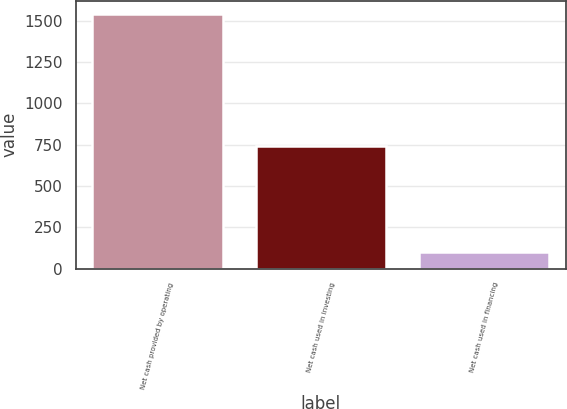Convert chart. <chart><loc_0><loc_0><loc_500><loc_500><bar_chart><fcel>Net cash provided by operating<fcel>Net cash used in investing<fcel>Net cash used in financing<nl><fcel>1542<fcel>743<fcel>102<nl></chart> 